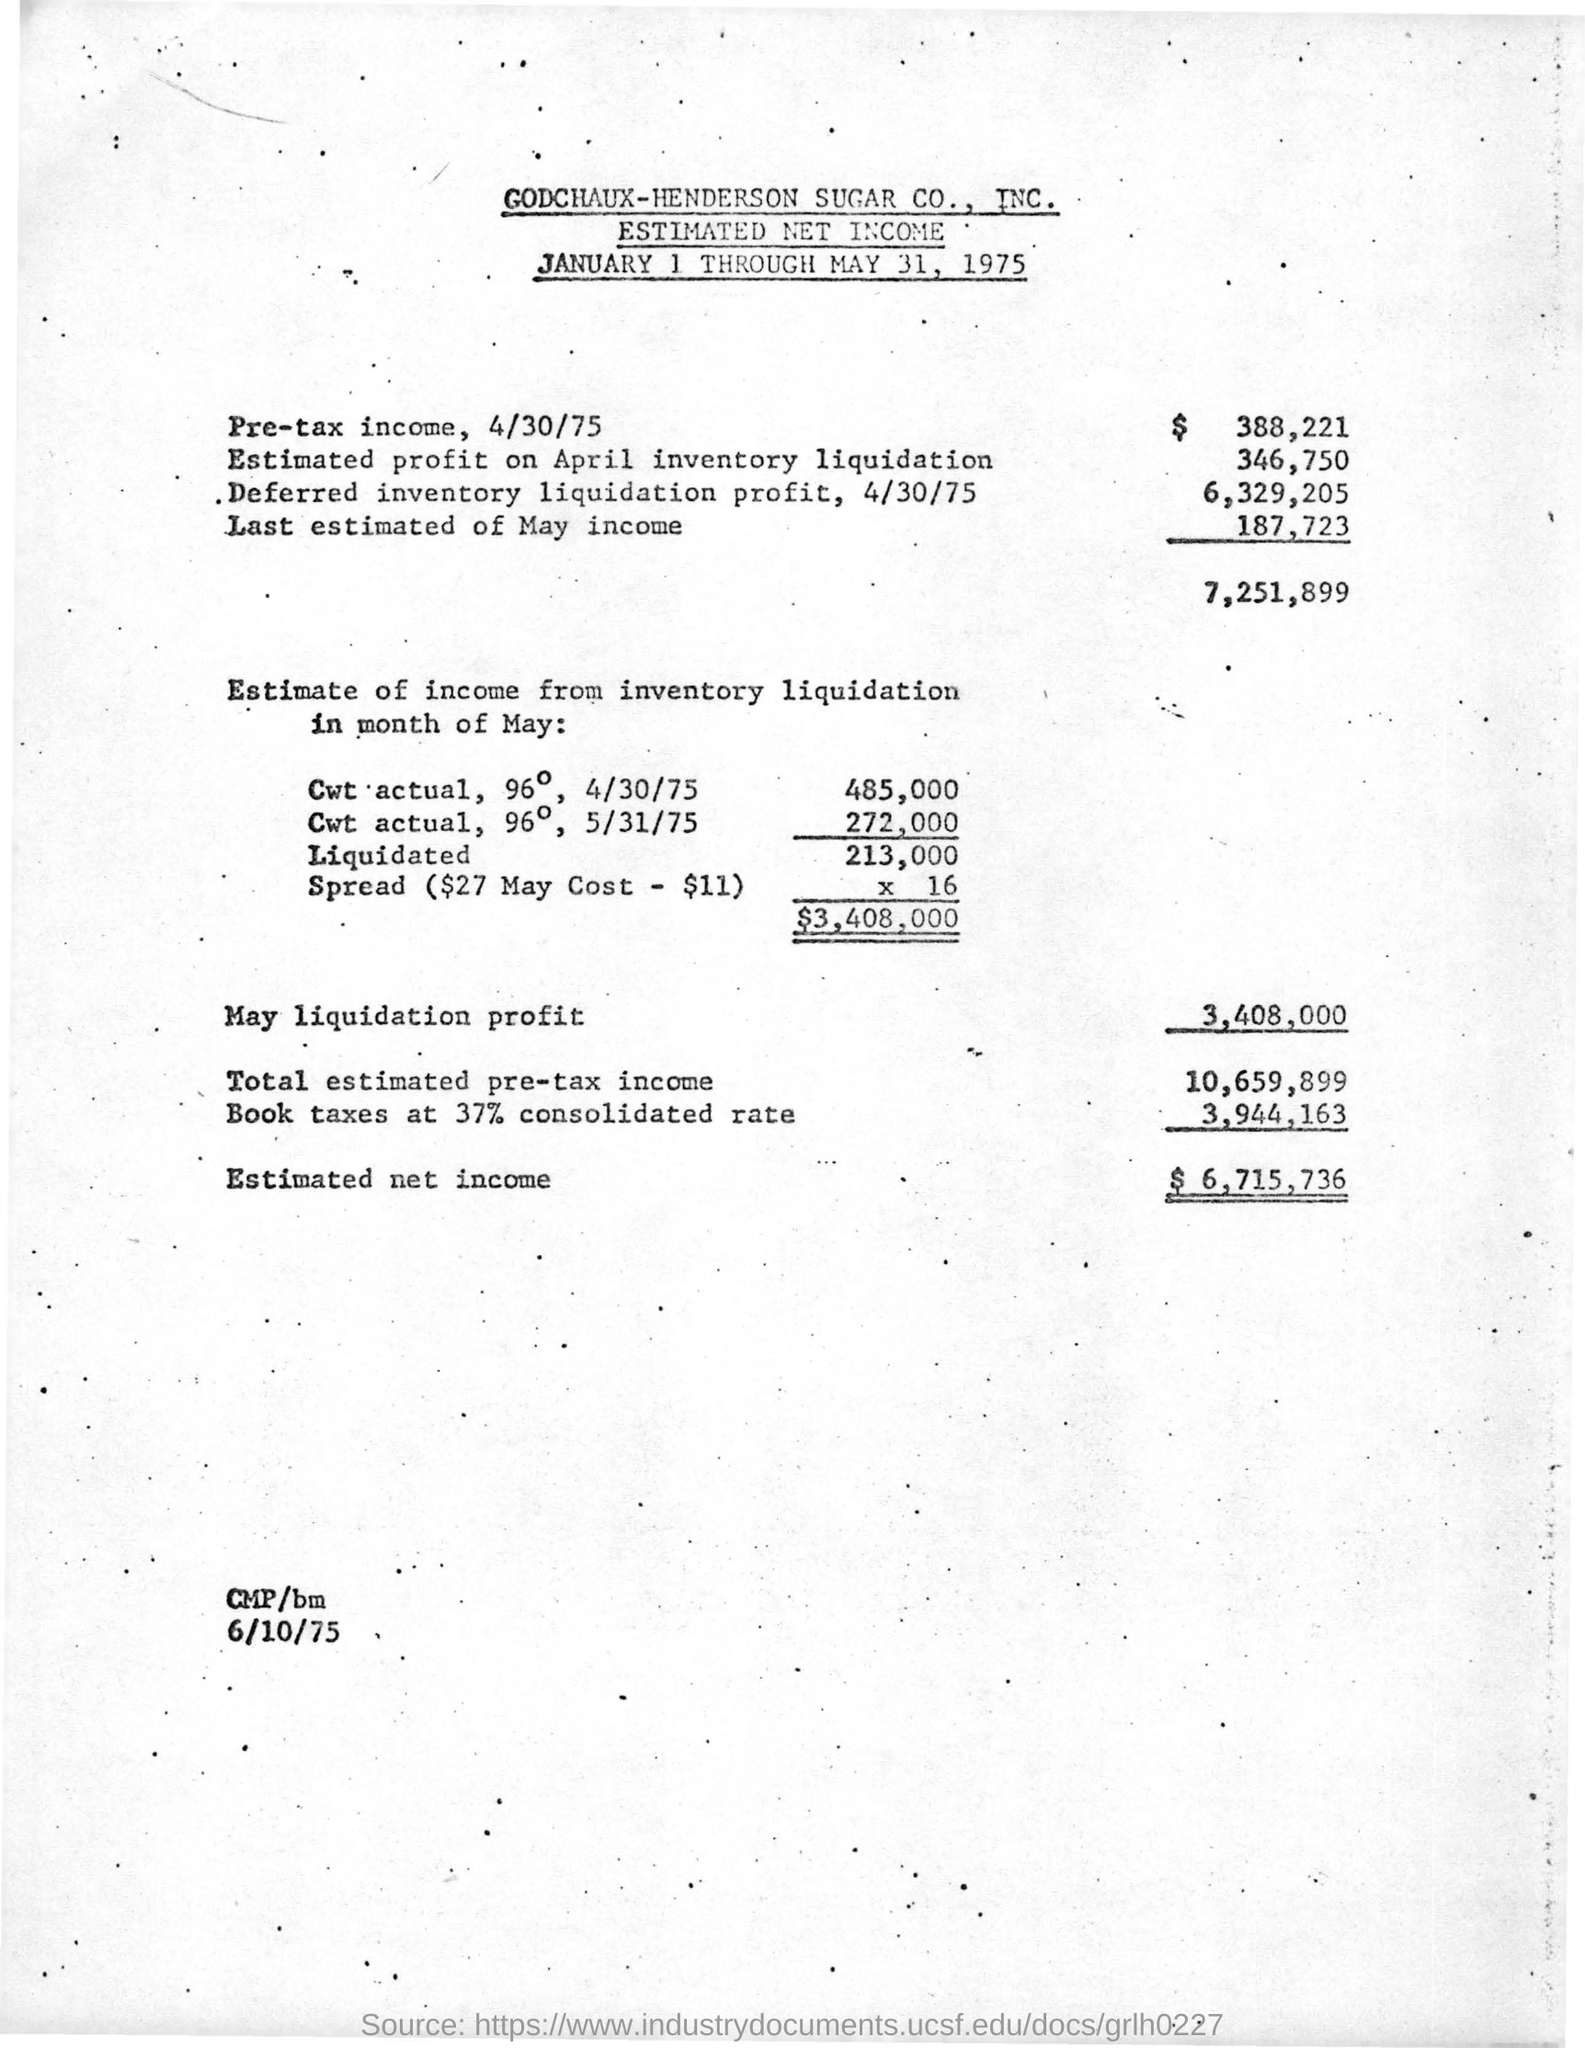Specify some key components in this picture. The pre-tax income on April 30, 1975 was $388,221. The estimated profit on the April inventory liquidation is approximately 346,750. The estimated net income is approximately $6,715,736. The estimated net income of GODCHAUX-HENDERSON SUGAR CO., INC. is given. 